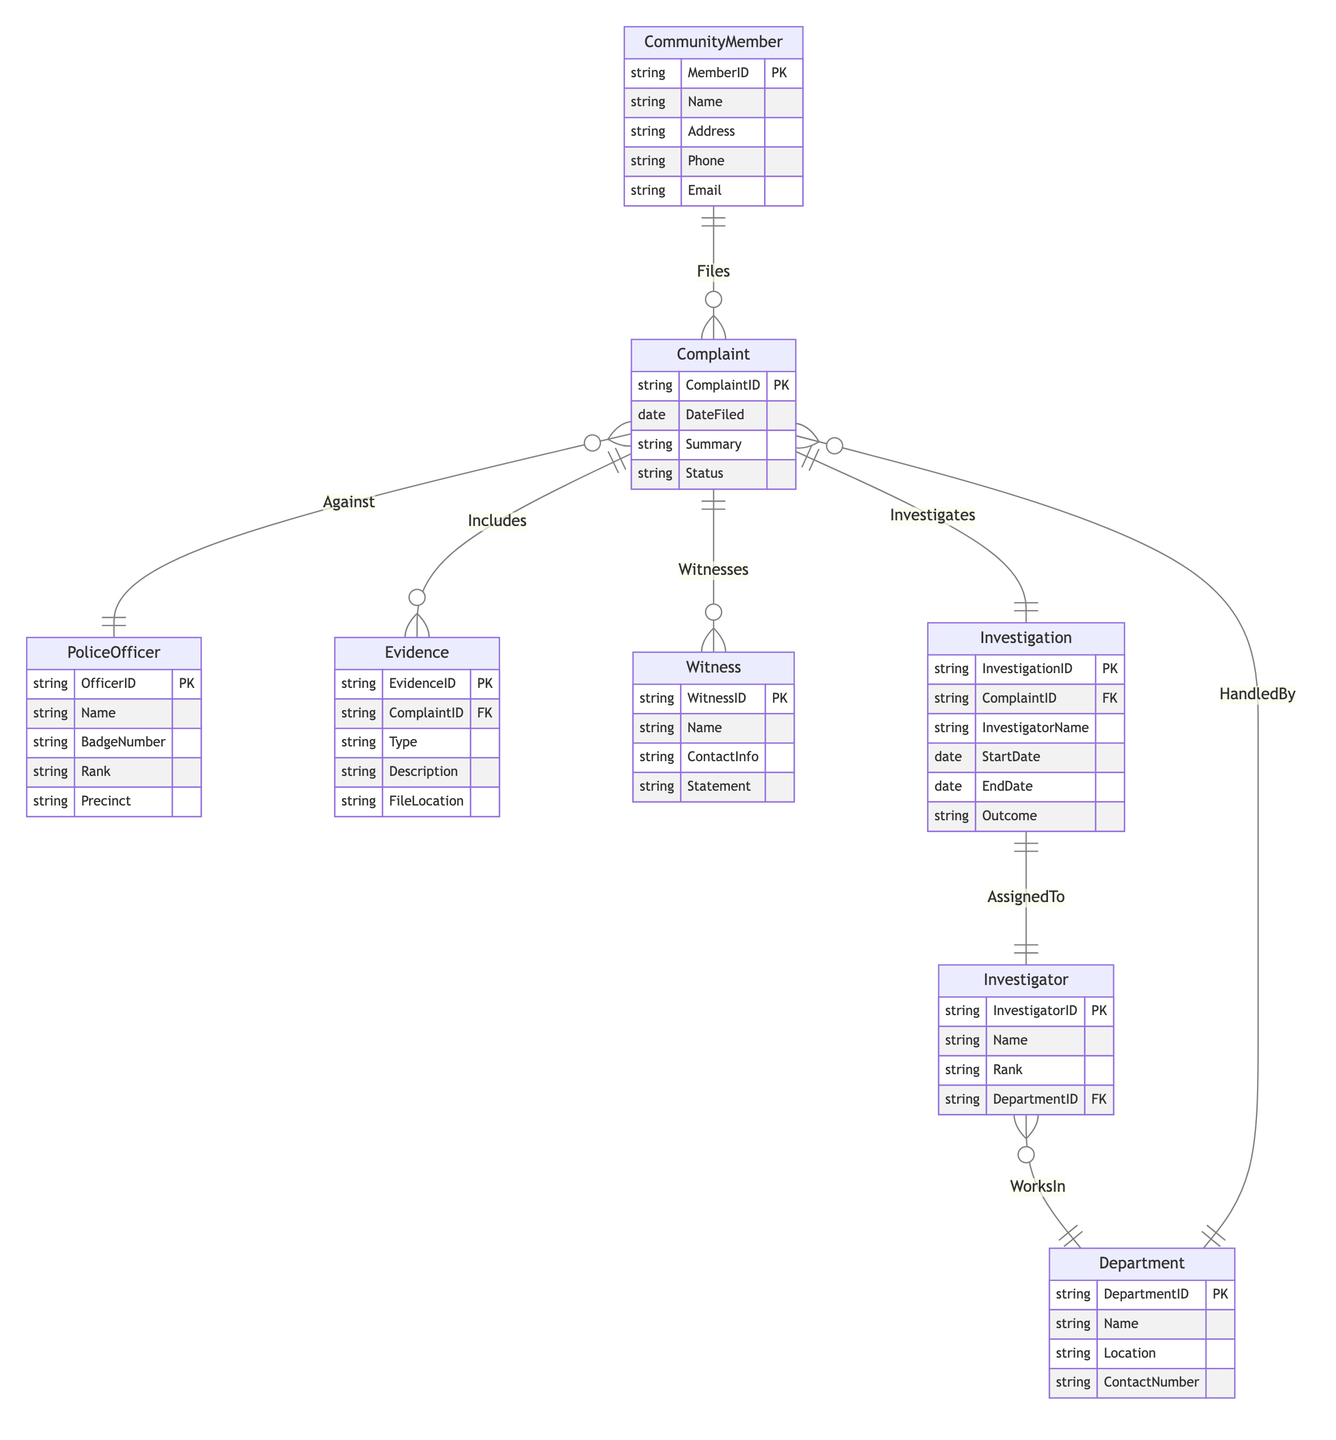What is the key entity that a Community Member uses to report misconduct? In the diagram, the relationship "Files" connects the "CommunityMember" to the "Complaint". This indicates that the primary entity for reporting police misconduct is the Complaint entity, which is filed by the Community Member.
Answer: Complaint How many attributes does the PoliceOfficer entity have? By analyzing the "PoliceOfficer" entity in the diagram, we see that it contains five attributes: OfficerID, Name, BadgeNumber, Rank, and Precinct. Thus, the total count is five.
Answer: 5 What type of relationship exists between Complaint and PoliceOfficer? The diagram illustrates the relationship "Against" between "Complaint" and "PoliceOfficer". This indicates that a complaint can be made against one or more police officers but is specifically classified as a one-to-many relationship.
Answer: 1:N What is the maximum number of witnesses that can be associated with a single Complaint? The relationship "Witnesses" signifies that a complaint can have multiple witnesses associated with it. In this case, the relationship is modeled as one-to-many (1:M), meaning a single complaint can have zero or more witnesses. Thus, there is no strict maximum.
Answer: M Who is assigned to investigate a Complaint? The relationship "Investigates" in the diagram connects the "Investigation" entity to the "Complaint" entity, indicating that each complaint has one associated investigation. This investigation is conducted by an "Investigator" determined by the "AssignedTo" relationship.
Answer: Investigator What does the status of a Complaint indicate? The "Status" attribute in the "Complaint" entity reveals its current state in the process of being handled or resolved, representing the progression or outcome of the complaint filing.
Answer: Current state Which department is responsible for handling the Complaint? The relationship "HandledBy" from "Complaint" to "Department" denotes that each complaint is associated with exactly one department responsible for its resolution or investigation.
Answer: Department What information is included in the Evidence associated with a Complaint? The "Evidence" entity features attributes that supply crucial details tied to a complaint, including the type of evidence, description, and file location. This information enhances the investigation's foundation by providing tangible proof.
Answer: Type, Description, FileLocation 